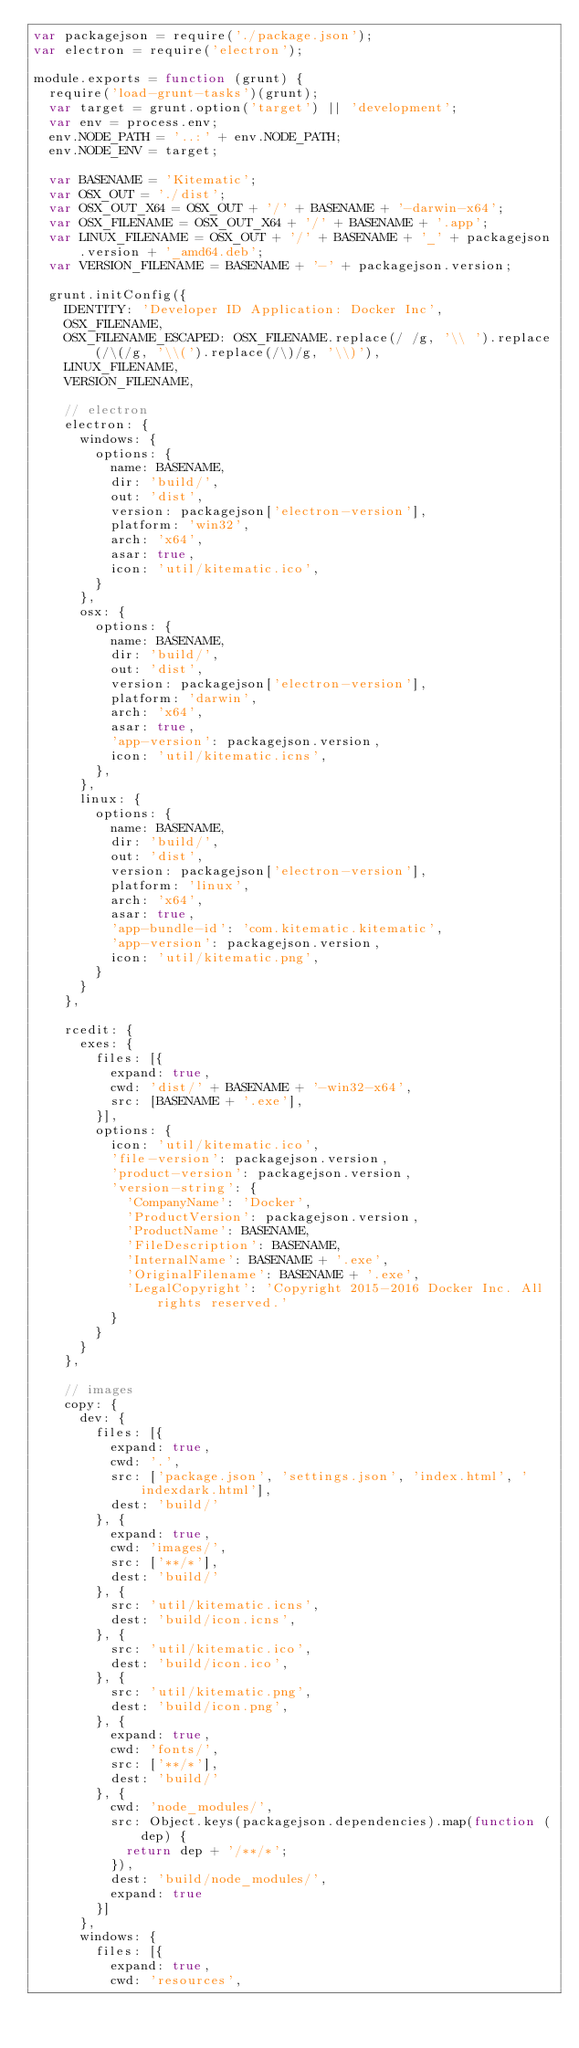<code> <loc_0><loc_0><loc_500><loc_500><_JavaScript_>var packagejson = require('./package.json');
var electron = require('electron');

module.exports = function (grunt) {
  require('load-grunt-tasks')(grunt);
  var target = grunt.option('target') || 'development';
  var env = process.env;
  env.NODE_PATH = '..:' + env.NODE_PATH;
  env.NODE_ENV = target;

  var BASENAME = 'Kitematic';
  var OSX_OUT = './dist';
  var OSX_OUT_X64 = OSX_OUT + '/' + BASENAME + '-darwin-x64';
  var OSX_FILENAME = OSX_OUT_X64 + '/' + BASENAME + '.app';
  var LINUX_FILENAME = OSX_OUT + '/' + BASENAME + '_' + packagejson.version + '_amd64.deb';
  var VERSION_FILENAME = BASENAME + '-' + packagejson.version;

  grunt.initConfig({
    IDENTITY: 'Developer ID Application: Docker Inc',
    OSX_FILENAME,
    OSX_FILENAME_ESCAPED: OSX_FILENAME.replace(/ /g, '\\ ').replace(/\(/g, '\\(').replace(/\)/g, '\\)'),
    LINUX_FILENAME,
    VERSION_FILENAME,

    // electron
    electron: {
      windows: {
        options: {
          name: BASENAME,
          dir: 'build/',
          out: 'dist',
          version: packagejson['electron-version'],
          platform: 'win32',
          arch: 'x64',
          asar: true,
          icon: 'util/kitematic.ico',
        }
      },
      osx: {
        options: {
          name: BASENAME,
          dir: 'build/',
          out: 'dist',
          version: packagejson['electron-version'],
          platform: 'darwin',
          arch: 'x64',
          asar: true,
          'app-version': packagejson.version,
          icon: 'util/kitematic.icns',
        },
      },
      linux: {
        options: {
          name: BASENAME,
          dir: 'build/',
          out: 'dist',
          version: packagejson['electron-version'],
          platform: 'linux',
          arch: 'x64',
          asar: true,
          'app-bundle-id': 'com.kitematic.kitematic',
          'app-version': packagejson.version,
          icon: 'util/kitematic.png',
        }
      }
    },

    rcedit: {
      exes: {
        files: [{
          expand: true,
          cwd: 'dist/' + BASENAME + '-win32-x64',
          src: [BASENAME + '.exe'],
        }],
        options: {
          icon: 'util/kitematic.ico',
          'file-version': packagejson.version,
          'product-version': packagejson.version,
          'version-string': {
            'CompanyName': 'Docker',
            'ProductVersion': packagejson.version,
            'ProductName': BASENAME,
            'FileDescription': BASENAME,
            'InternalName': BASENAME + '.exe',
            'OriginalFilename': BASENAME + '.exe',
            'LegalCopyright': 'Copyright 2015-2016 Docker Inc. All rights reserved.'
          }
        }
      }
    },

    // images
    copy: {
      dev: {
        files: [{
          expand: true,
          cwd: '.',
          src: ['package.json', 'settings.json', 'index.html', 'indexdark.html'],
          dest: 'build/'
        }, {
          expand: true,
          cwd: 'images/',
          src: ['**/*'],
          dest: 'build/'
        }, {
          src: 'util/kitematic.icns',
          dest: 'build/icon.icns',
        }, {
          src: 'util/kitematic.ico',
          dest: 'build/icon.ico',
        }, {
          src: 'util/kitematic.png',
          dest: 'build/icon.png',
        }, {
          expand: true,
          cwd: 'fonts/',
          src: ['**/*'],
          dest: 'build/'
        }, {
          cwd: 'node_modules/',
          src: Object.keys(packagejson.dependencies).map(function (dep) {
            return dep + '/**/*';
          }),
          dest: 'build/node_modules/',
          expand: true
        }]
      },
      windows: {
        files: [{
          expand: true,
          cwd: 'resources',</code> 